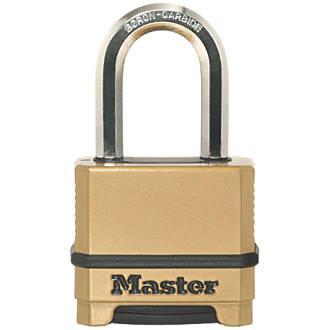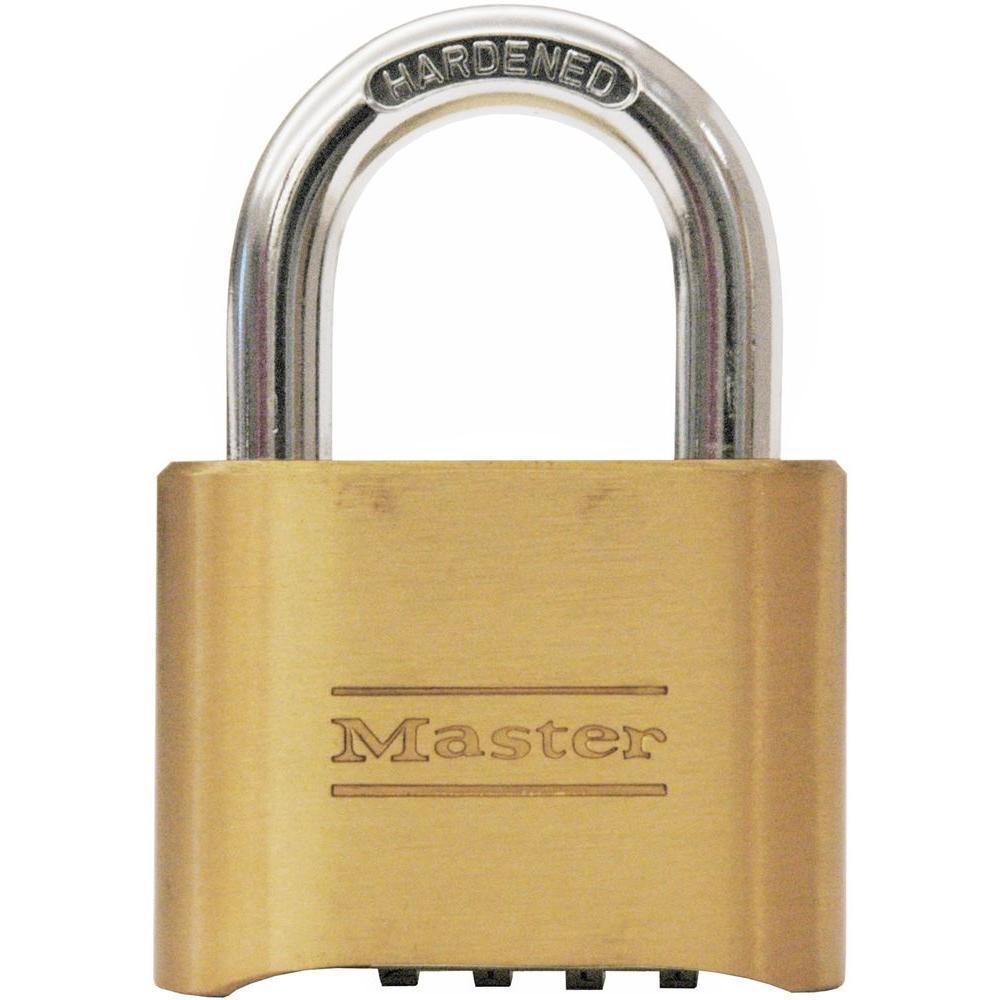The first image is the image on the left, the second image is the image on the right. Given the left and right images, does the statement "At least one of the locks has a black body with at least three rows of combination wheels on its front." hold true? Answer yes or no. No. The first image is the image on the left, the second image is the image on the right. Examine the images to the left and right. Is the description "One or more locks have their rotating discs showing on the side, while another lock does not have them on the side." accurate? Answer yes or no. No. 